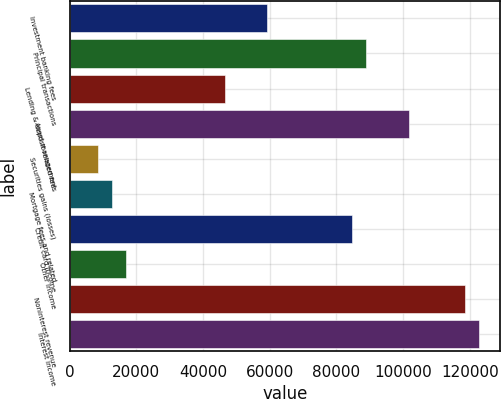Convert chart. <chart><loc_0><loc_0><loc_500><loc_500><bar_chart><fcel>Investment banking fees<fcel>Principal transactions<fcel>Lending & deposit related fees<fcel>Asset management<fcel>Securities gains (losses)<fcel>Mortgage fees and related<fcel>Credit card income<fcel>Other income<fcel>Noninterest revenue<fcel>Interest income<nl><fcel>59320.2<fcel>88979.6<fcel>46609<fcel>101691<fcel>8475.48<fcel>12712.5<fcel>84742.6<fcel>16949.6<fcel>118639<fcel>122876<nl></chart> 